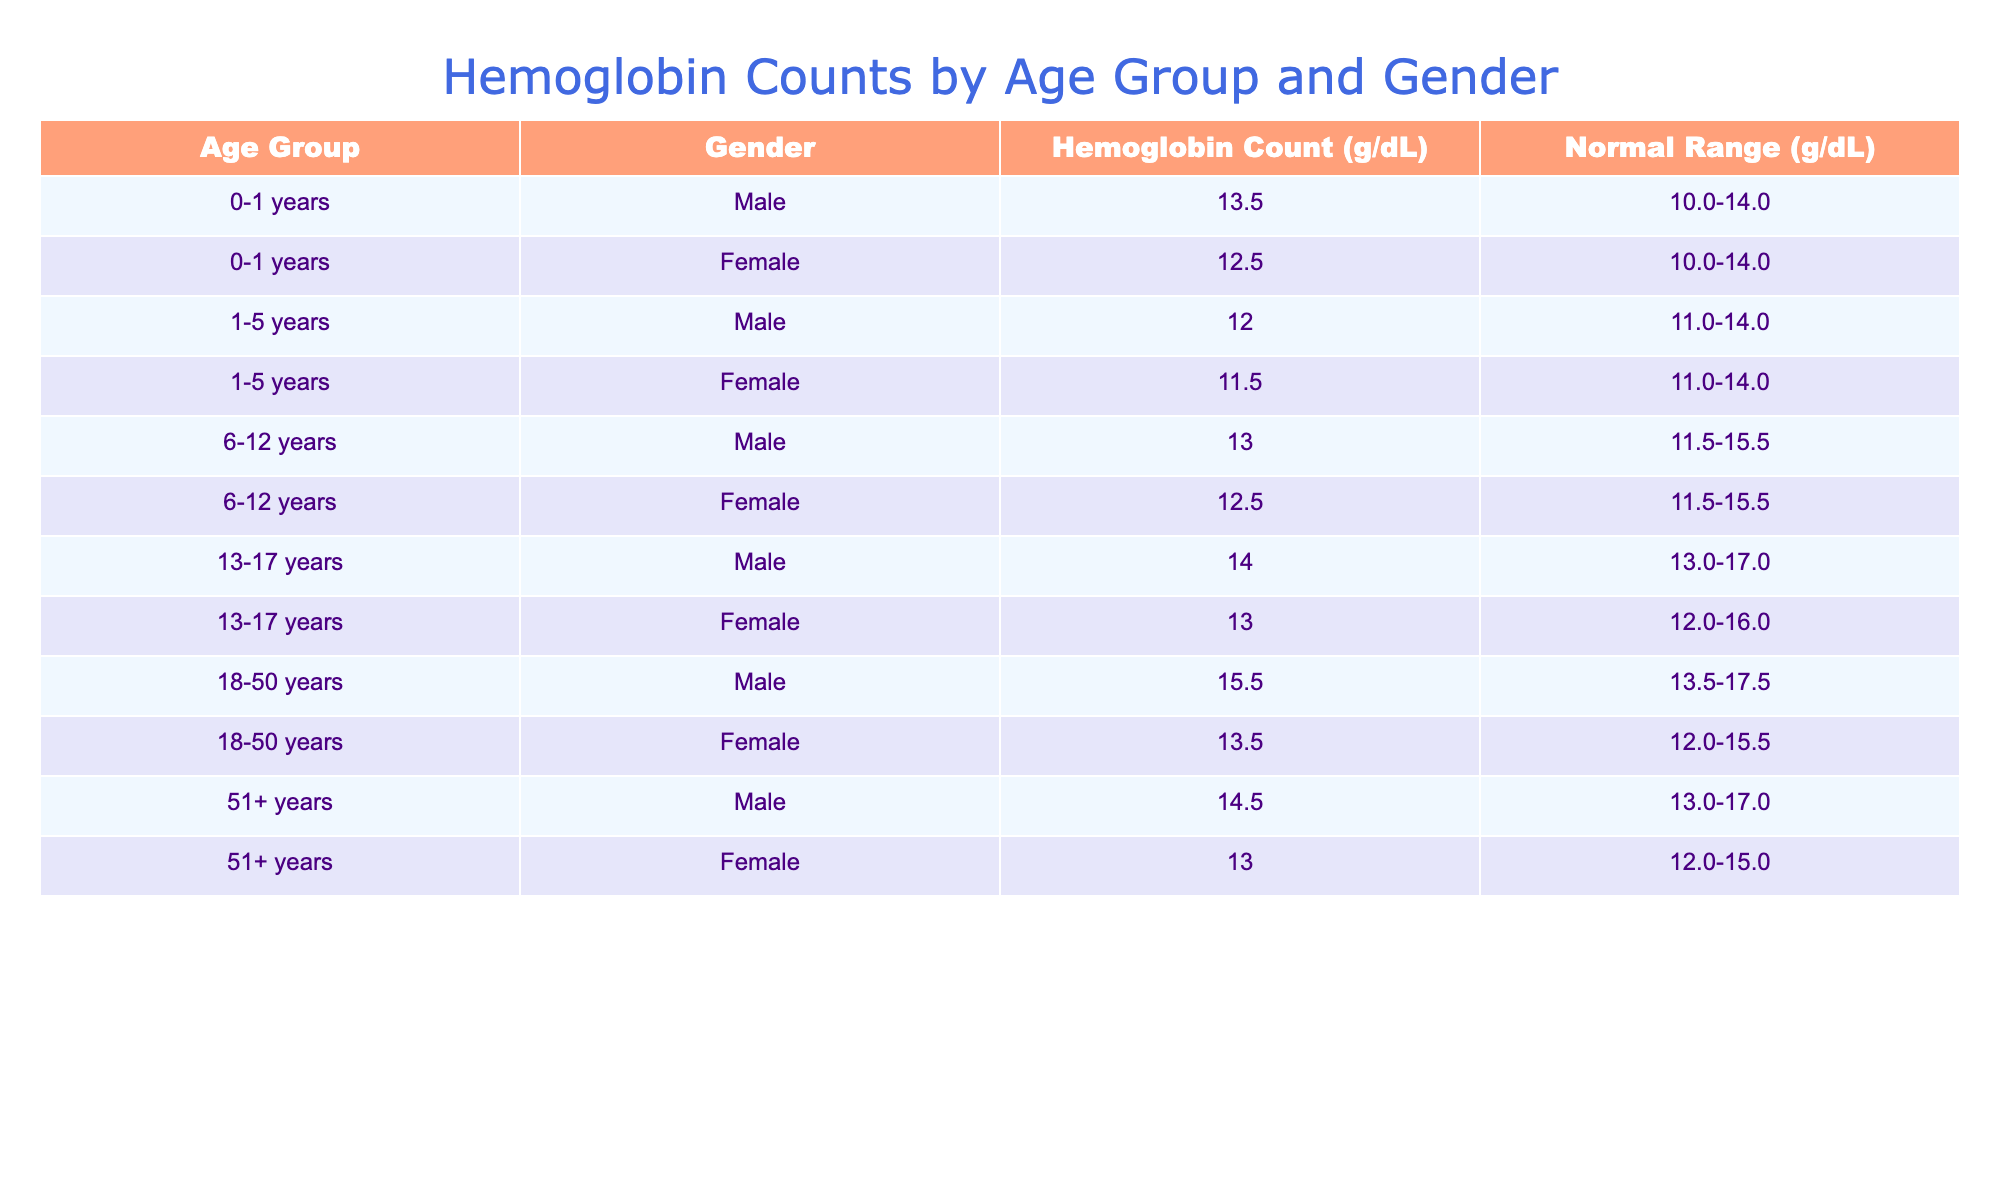What is the hemoglobin count for males in the age group 1-5 years? The table specifies that the hemoglobin count for males in the age group 1-5 years is listed in the corresponding row, which is 12.0 g/dL.
Answer: 12.0 g/dL What is the normal range for hemoglobin counts in females aged 51 years and older? According to the table, the normal range for hemoglobin counts in females aged 51+ years is 12.0-15.0 g/dL, found in the relevant row.
Answer: 12.0-15.0 g/dL Is the hemoglobin count for females aged 6-12 years higher than that for males in the same age group? The table shows that the hemoglobin count for females aged 6-12 years is 12.5 g/dL and for males is 13.0 g/dL. Since 12.5 is less than 13.0, the answer is no.
Answer: No What is the average hemoglobin count for males across all age groups? The hemoglobin counts for males are: 13.5, 12.0, 13.0, 14.0, 15.5, and 14.5 g/dL. To find the average, we sum these values (13.5 + 12.0 + 13.0 + 14.0 + 15.5 + 14.5 = 88.5) and divide by the number of data points (6). So, the average is 88.5 / 6 = 14.75 g/dL.
Answer: 14.75 g/dL Do males aged 18-50 years have higher hemoglobin counts compared to those aged 51 years and older? For males aged 18-50 years, the hemoglobin count is 15.5 g/dL, while for those aged 51 years and older, it is 14.5 g/dL. Since 15.5 is greater than 14.5, the answer is yes.
Answer: Yes What is the difference in hemoglobin counts between females aged 13-17 years and those aged 18-50 years? The hemoglobin count for females aged 13-17 years is 13.0 g/dL and for 18-50 years is 13.5 g/dL. The difference is computed as 13.5 - 13.0 = 0.5 g/dL.
Answer: 0.5 g/dL Which age group has the lowest hemoglobin count for males? By comparing all male hemoglobin counts across age groups, the minimum value is found with males aged 1-5 years at 12.0 g/dL. Thus, this is the answer.
Answer: 1-5 years How many individuals have a hemoglobin count that falls within the normal range for their respective gender and age group? We need to analyze each row for hemoglobin counts in relation to the normal ranges given. All rows meet their respective normal ranges; thus, there are 12 individuals total (6 males and 6 females) with counts within normal ranges.
Answer: 12 